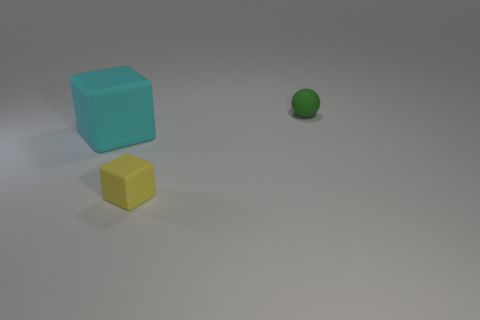Does the tiny thing in front of the green sphere have the same material as the cyan cube?
Offer a very short reply. Yes. Are there any other balls of the same color as the matte ball?
Make the answer very short. No. What shape is the small green matte object?
Your response must be concise. Sphere. There is a object on the left side of the tiny rubber thing that is to the left of the small green sphere; what color is it?
Your answer should be compact. Cyan. What is the size of the matte cube behind the yellow rubber block?
Provide a short and direct response. Large. Are there any small brown blocks that have the same material as the big block?
Offer a terse response. No. How many small green things have the same shape as the cyan object?
Your response must be concise. 0. What is the shape of the small rubber thing on the left side of the small object behind the block that is behind the yellow matte thing?
Your response must be concise. Cube. What material is the thing that is behind the small yellow object and to the right of the large block?
Your answer should be compact. Rubber. There is a rubber object on the left side of the yellow rubber thing; does it have the same size as the green matte sphere?
Your answer should be compact. No. 